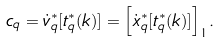Convert formula to latex. <formula><loc_0><loc_0><loc_500><loc_500>c _ { q } = \dot { v } _ { q } ^ { \ast } [ t _ { q } ^ { \ast } ( k ) ] = { \left [ { \dot { x } _ { q } ^ { \ast } [ t _ { q } ^ { \ast } ( k ) ] } \right ] } _ { 1 } .</formula> 